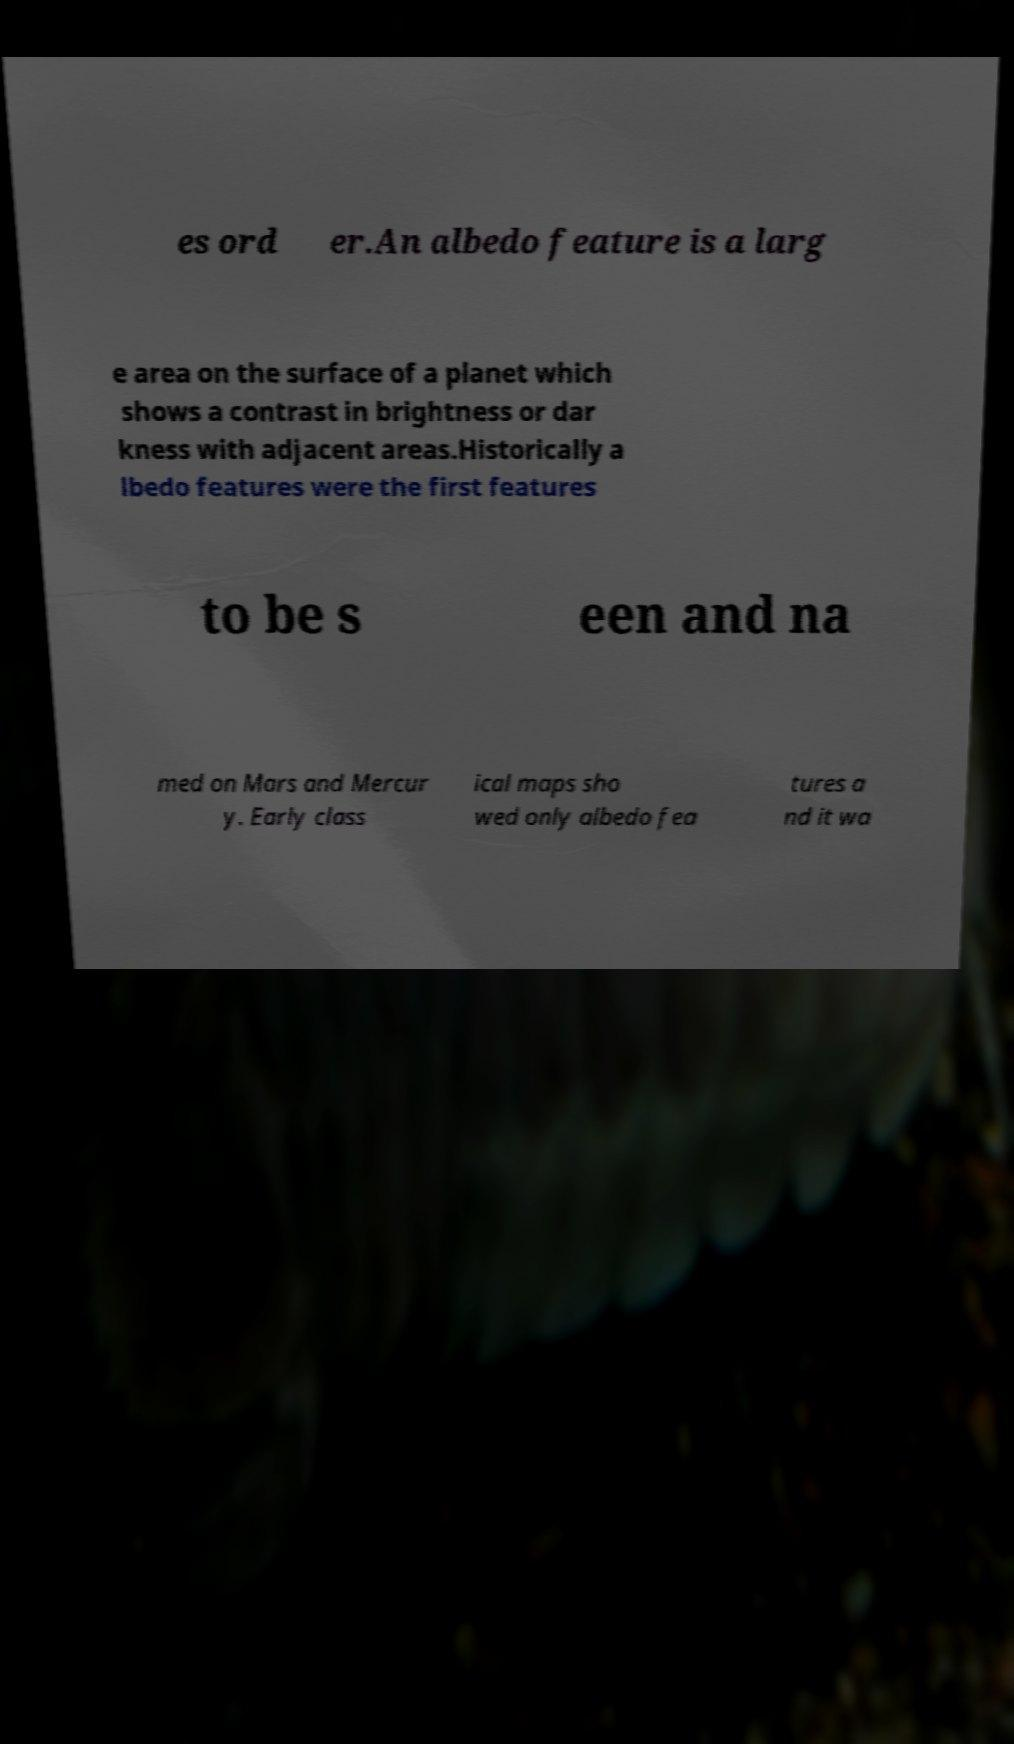There's text embedded in this image that I need extracted. Can you transcribe it verbatim? es ord er.An albedo feature is a larg e area on the surface of a planet which shows a contrast in brightness or dar kness with adjacent areas.Historically a lbedo features were the first features to be s een and na med on Mars and Mercur y. Early class ical maps sho wed only albedo fea tures a nd it wa 